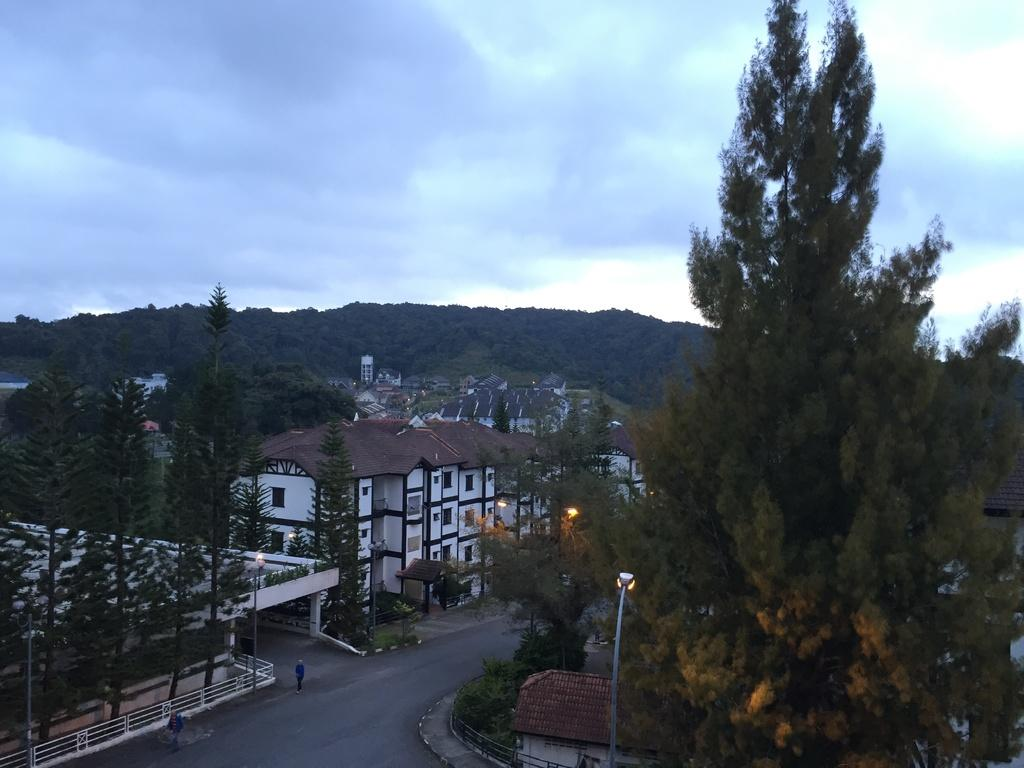What type of vegetation can be seen in the image? There are trees in the image. What color are the trees? The trees are in green color. What other structures are visible in the image? There are light poles and buildings in the image. What colors are the buildings? The buildings are in white and cream color. What can be seen in the sky in the image? The sky is in white and blue color. Can you see any steam coming from the trees in the image? There is no steam present in the image; it only shows trees, light poles, buildings, and the sky. Is there a frog sitting on top of one of the buildings in the image? There is no frog present in the image; it only shows trees, light poles, buildings, and the sky. 